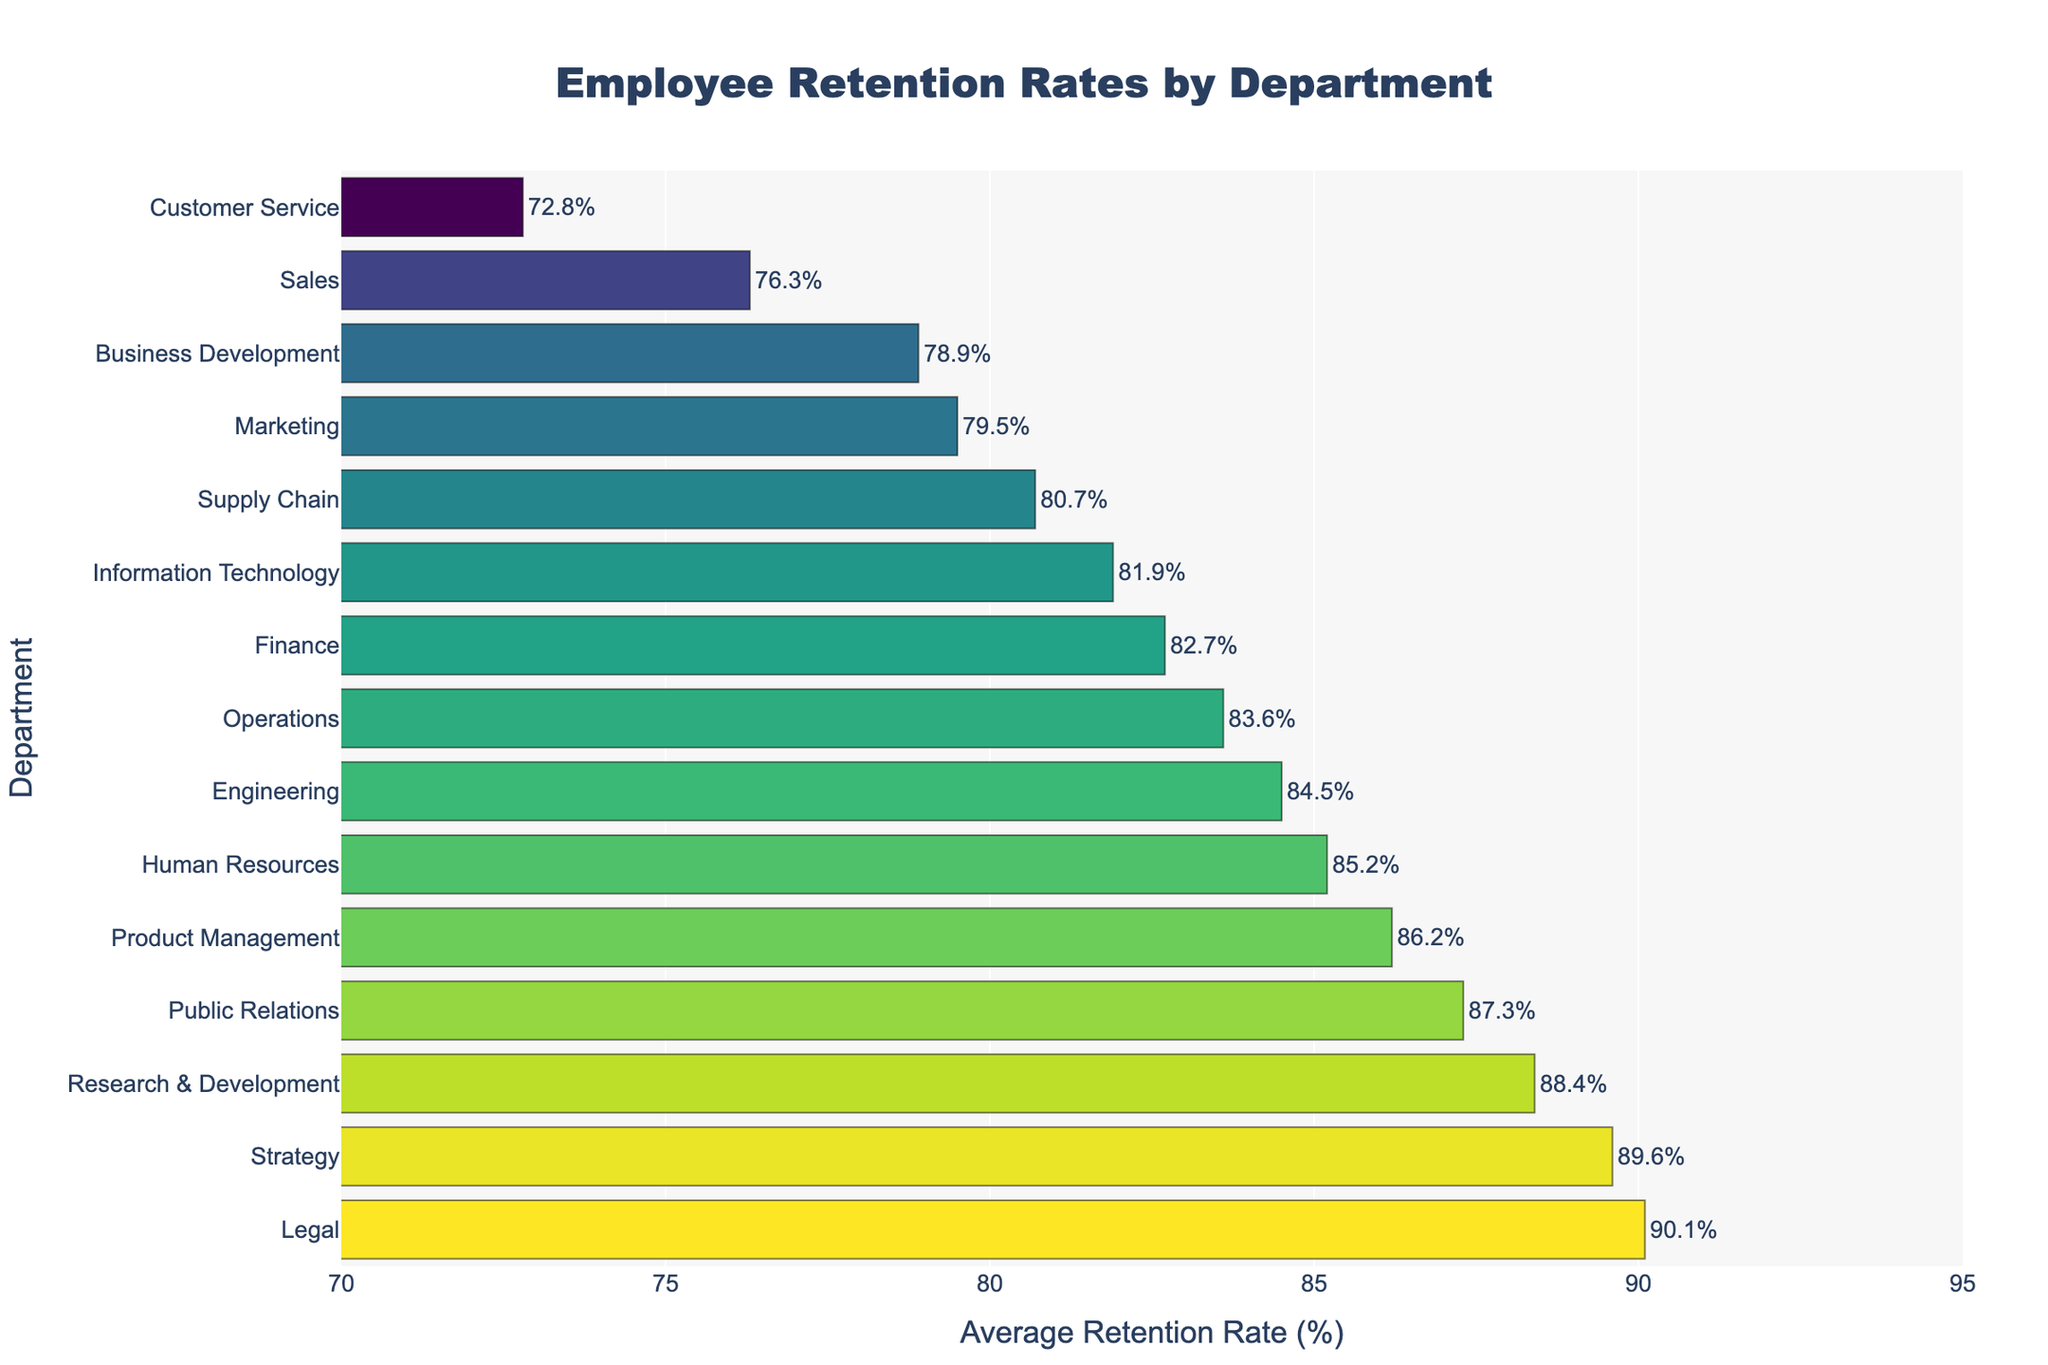what's the department with the highest retention rate? The department with the highest retention rate is the one with the tallest bar on the bar chart, reaching the highest point on the x-axis. The bar for the Legal department reaches the highest point at 90.1%.
Answer: Legal what's the difference in retention rates between the department with the highest and the lowest retention rates? To find the difference, subtract the lowest retention rate (Customer Service, 72.8%) from the highest retention rate (Legal, 90.1%). This results in 90.1% - 72.8% = 17.3%.
Answer: 17.3% which department has a higher retention rate, Finance or Operations? The retention rate for Finance is 82.7%, and for Operations, it is 83.6%. Comparing these two values, 83.6% is higher than 82.7%.
Answer: Operations how many departments have retention rates above 85%? The departments above 85% retention are Human Resources (85.2%), Research & Development (88.4%), Legal (90.1%), Engineering (84.5%), Product Management (86.2%), Public Relations (87.3%), and Strategy (89.6%). There are 7 departments in total.
Answer: 7 if we exclude the top three departments with the highest retention rates, what's the average retention rate of the remaining departments? Excluding the top three departments (Legal 90.1%, Strategy 89.6%, and Research & Development 88.4%), we sum the retention rates of the remaining 12 departments and divide by 12. The total for the remaining departments is 1083.3%, divided by 12, which results in 90.27 / 12 = 83.17%.
Answer: 83.17 which department has a lower retention rate, Marketing or Product Management? The retention rate for Marketing is 79.5%, and for Product Management, it is 86.2%. Comparing these two values, 79.5% is lower than 86.2%.
Answer: Marketing 